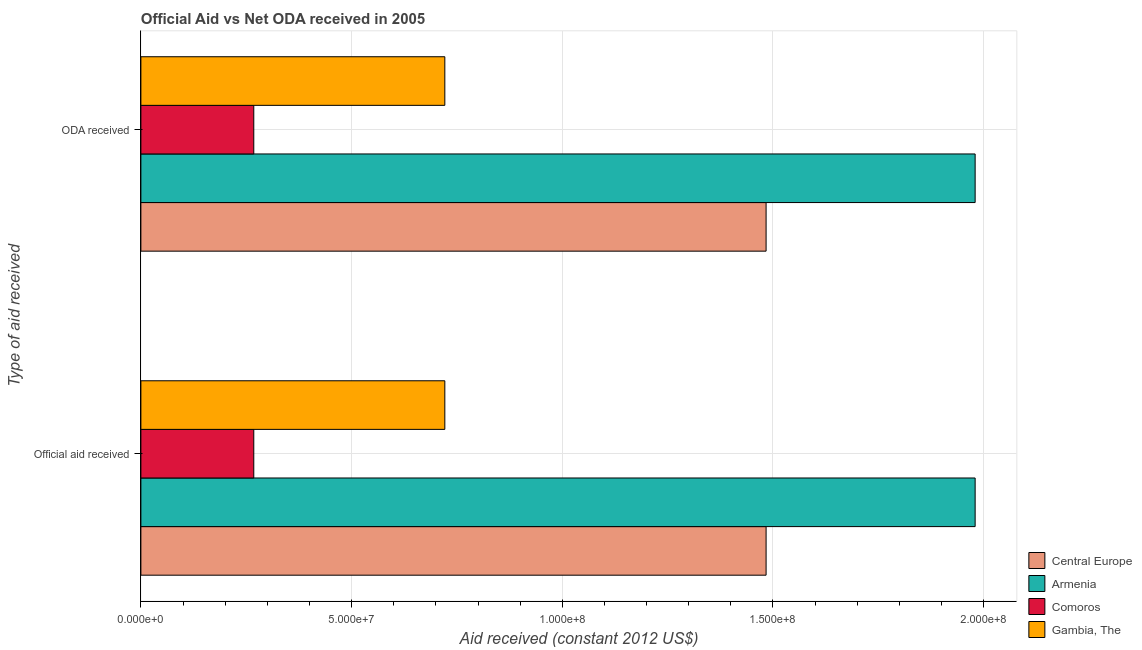Are the number of bars per tick equal to the number of legend labels?
Your response must be concise. Yes. Are the number of bars on each tick of the Y-axis equal?
Make the answer very short. Yes. What is the label of the 1st group of bars from the top?
Keep it short and to the point. ODA received. What is the official aid received in Comoros?
Your answer should be very brief. 2.68e+07. Across all countries, what is the maximum oda received?
Keep it short and to the point. 1.98e+08. Across all countries, what is the minimum official aid received?
Provide a succinct answer. 2.68e+07. In which country was the official aid received maximum?
Your response must be concise. Armenia. In which country was the oda received minimum?
Your answer should be compact. Comoros. What is the total oda received in the graph?
Keep it short and to the point. 4.45e+08. What is the difference between the official aid received in Armenia and that in Gambia, The?
Ensure brevity in your answer.  1.26e+08. What is the difference between the oda received in Comoros and the official aid received in Gambia, The?
Your response must be concise. -4.53e+07. What is the average official aid received per country?
Make the answer very short. 1.11e+08. What is the difference between the oda received and official aid received in Central Europe?
Offer a very short reply. 0. In how many countries, is the official aid received greater than 50000000 US$?
Your answer should be very brief. 3. What is the ratio of the oda received in Comoros to that in Armenia?
Keep it short and to the point. 0.14. What does the 2nd bar from the top in Official aid received represents?
Give a very brief answer. Comoros. What does the 1st bar from the bottom in Official aid received represents?
Your response must be concise. Central Europe. How many bars are there?
Your response must be concise. 8. Are all the bars in the graph horizontal?
Provide a short and direct response. Yes. How many countries are there in the graph?
Make the answer very short. 4. What is the difference between two consecutive major ticks on the X-axis?
Give a very brief answer. 5.00e+07. Does the graph contain grids?
Offer a terse response. Yes. How are the legend labels stacked?
Provide a succinct answer. Vertical. What is the title of the graph?
Provide a succinct answer. Official Aid vs Net ODA received in 2005 . Does "Sint Maarten (Dutch part)" appear as one of the legend labels in the graph?
Provide a succinct answer. No. What is the label or title of the X-axis?
Give a very brief answer. Aid received (constant 2012 US$). What is the label or title of the Y-axis?
Offer a very short reply. Type of aid received. What is the Aid received (constant 2012 US$) in Central Europe in Official aid received?
Your response must be concise. 1.48e+08. What is the Aid received (constant 2012 US$) of Armenia in Official aid received?
Make the answer very short. 1.98e+08. What is the Aid received (constant 2012 US$) in Comoros in Official aid received?
Your response must be concise. 2.68e+07. What is the Aid received (constant 2012 US$) in Gambia, The in Official aid received?
Offer a terse response. 7.21e+07. What is the Aid received (constant 2012 US$) in Central Europe in ODA received?
Offer a very short reply. 1.48e+08. What is the Aid received (constant 2012 US$) in Armenia in ODA received?
Give a very brief answer. 1.98e+08. What is the Aid received (constant 2012 US$) of Comoros in ODA received?
Keep it short and to the point. 2.68e+07. What is the Aid received (constant 2012 US$) in Gambia, The in ODA received?
Provide a short and direct response. 7.21e+07. Across all Type of aid received, what is the maximum Aid received (constant 2012 US$) in Central Europe?
Your response must be concise. 1.48e+08. Across all Type of aid received, what is the maximum Aid received (constant 2012 US$) in Armenia?
Offer a terse response. 1.98e+08. Across all Type of aid received, what is the maximum Aid received (constant 2012 US$) of Comoros?
Ensure brevity in your answer.  2.68e+07. Across all Type of aid received, what is the maximum Aid received (constant 2012 US$) in Gambia, The?
Your response must be concise. 7.21e+07. Across all Type of aid received, what is the minimum Aid received (constant 2012 US$) of Central Europe?
Provide a succinct answer. 1.48e+08. Across all Type of aid received, what is the minimum Aid received (constant 2012 US$) of Armenia?
Your response must be concise. 1.98e+08. Across all Type of aid received, what is the minimum Aid received (constant 2012 US$) of Comoros?
Ensure brevity in your answer.  2.68e+07. Across all Type of aid received, what is the minimum Aid received (constant 2012 US$) in Gambia, The?
Your answer should be very brief. 7.21e+07. What is the total Aid received (constant 2012 US$) of Central Europe in the graph?
Your response must be concise. 2.97e+08. What is the total Aid received (constant 2012 US$) in Armenia in the graph?
Ensure brevity in your answer.  3.96e+08. What is the total Aid received (constant 2012 US$) in Comoros in the graph?
Provide a short and direct response. 5.36e+07. What is the total Aid received (constant 2012 US$) in Gambia, The in the graph?
Your answer should be compact. 1.44e+08. What is the difference between the Aid received (constant 2012 US$) of Central Europe in Official aid received and the Aid received (constant 2012 US$) of Armenia in ODA received?
Your answer should be very brief. -4.96e+07. What is the difference between the Aid received (constant 2012 US$) in Central Europe in Official aid received and the Aid received (constant 2012 US$) in Comoros in ODA received?
Offer a very short reply. 1.22e+08. What is the difference between the Aid received (constant 2012 US$) of Central Europe in Official aid received and the Aid received (constant 2012 US$) of Gambia, The in ODA received?
Provide a short and direct response. 7.62e+07. What is the difference between the Aid received (constant 2012 US$) of Armenia in Official aid received and the Aid received (constant 2012 US$) of Comoros in ODA received?
Your answer should be very brief. 1.71e+08. What is the difference between the Aid received (constant 2012 US$) of Armenia in Official aid received and the Aid received (constant 2012 US$) of Gambia, The in ODA received?
Make the answer very short. 1.26e+08. What is the difference between the Aid received (constant 2012 US$) of Comoros in Official aid received and the Aid received (constant 2012 US$) of Gambia, The in ODA received?
Offer a very short reply. -4.53e+07. What is the average Aid received (constant 2012 US$) in Central Europe per Type of aid received?
Offer a very short reply. 1.48e+08. What is the average Aid received (constant 2012 US$) of Armenia per Type of aid received?
Offer a very short reply. 1.98e+08. What is the average Aid received (constant 2012 US$) in Comoros per Type of aid received?
Make the answer very short. 2.68e+07. What is the average Aid received (constant 2012 US$) in Gambia, The per Type of aid received?
Your answer should be very brief. 7.21e+07. What is the difference between the Aid received (constant 2012 US$) of Central Europe and Aid received (constant 2012 US$) of Armenia in Official aid received?
Offer a very short reply. -4.96e+07. What is the difference between the Aid received (constant 2012 US$) in Central Europe and Aid received (constant 2012 US$) in Comoros in Official aid received?
Provide a succinct answer. 1.22e+08. What is the difference between the Aid received (constant 2012 US$) of Central Europe and Aid received (constant 2012 US$) of Gambia, The in Official aid received?
Provide a short and direct response. 7.62e+07. What is the difference between the Aid received (constant 2012 US$) in Armenia and Aid received (constant 2012 US$) in Comoros in Official aid received?
Offer a terse response. 1.71e+08. What is the difference between the Aid received (constant 2012 US$) in Armenia and Aid received (constant 2012 US$) in Gambia, The in Official aid received?
Ensure brevity in your answer.  1.26e+08. What is the difference between the Aid received (constant 2012 US$) of Comoros and Aid received (constant 2012 US$) of Gambia, The in Official aid received?
Provide a succinct answer. -4.53e+07. What is the difference between the Aid received (constant 2012 US$) of Central Europe and Aid received (constant 2012 US$) of Armenia in ODA received?
Give a very brief answer. -4.96e+07. What is the difference between the Aid received (constant 2012 US$) in Central Europe and Aid received (constant 2012 US$) in Comoros in ODA received?
Your answer should be very brief. 1.22e+08. What is the difference between the Aid received (constant 2012 US$) of Central Europe and Aid received (constant 2012 US$) of Gambia, The in ODA received?
Give a very brief answer. 7.62e+07. What is the difference between the Aid received (constant 2012 US$) of Armenia and Aid received (constant 2012 US$) of Comoros in ODA received?
Give a very brief answer. 1.71e+08. What is the difference between the Aid received (constant 2012 US$) of Armenia and Aid received (constant 2012 US$) of Gambia, The in ODA received?
Keep it short and to the point. 1.26e+08. What is the difference between the Aid received (constant 2012 US$) in Comoros and Aid received (constant 2012 US$) in Gambia, The in ODA received?
Provide a short and direct response. -4.53e+07. What is the ratio of the Aid received (constant 2012 US$) in Armenia in Official aid received to that in ODA received?
Provide a succinct answer. 1. What is the ratio of the Aid received (constant 2012 US$) in Comoros in Official aid received to that in ODA received?
Give a very brief answer. 1. What is the ratio of the Aid received (constant 2012 US$) of Gambia, The in Official aid received to that in ODA received?
Keep it short and to the point. 1. What is the difference between the highest and the second highest Aid received (constant 2012 US$) in Central Europe?
Your answer should be compact. 0. What is the difference between the highest and the second highest Aid received (constant 2012 US$) in Armenia?
Provide a short and direct response. 0. What is the difference between the highest and the second highest Aid received (constant 2012 US$) of Comoros?
Make the answer very short. 0. 